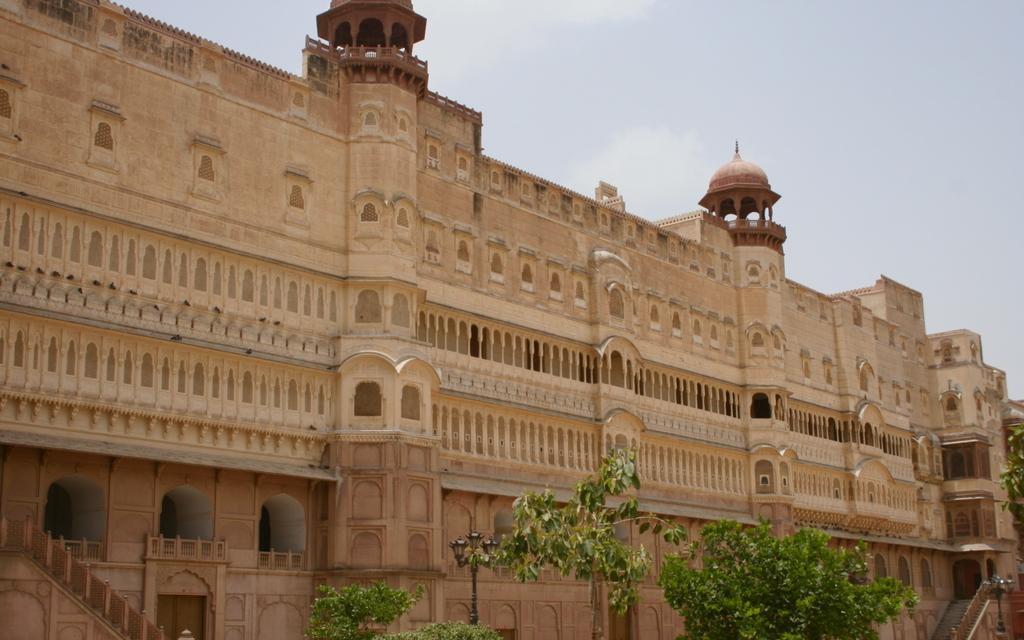Describe this image in one or two sentences. At the bottom of this image, there are trees having green color leaves. In the background, there is a building having windows and there are clouds in the sky. 